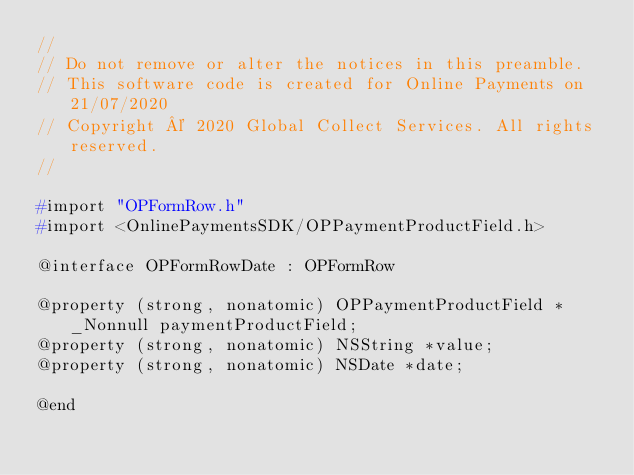Convert code to text. <code><loc_0><loc_0><loc_500><loc_500><_C_>//
// Do not remove or alter the notices in this preamble.
// This software code is created for Online Payments on 21/07/2020
// Copyright © 2020 Global Collect Services. All rights reserved.
//

#import "OPFormRow.h"
#import <OnlinePaymentsSDK/OPPaymentProductField.h>

@interface OPFormRowDate : OPFormRow

@property (strong, nonatomic) OPPaymentProductField * _Nonnull paymentProductField;
@property (strong, nonatomic) NSString *value;
@property (strong, nonatomic) NSDate *date;

@end
</code> 